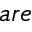<formula> <loc_0><loc_0><loc_500><loc_500>a r e</formula> 